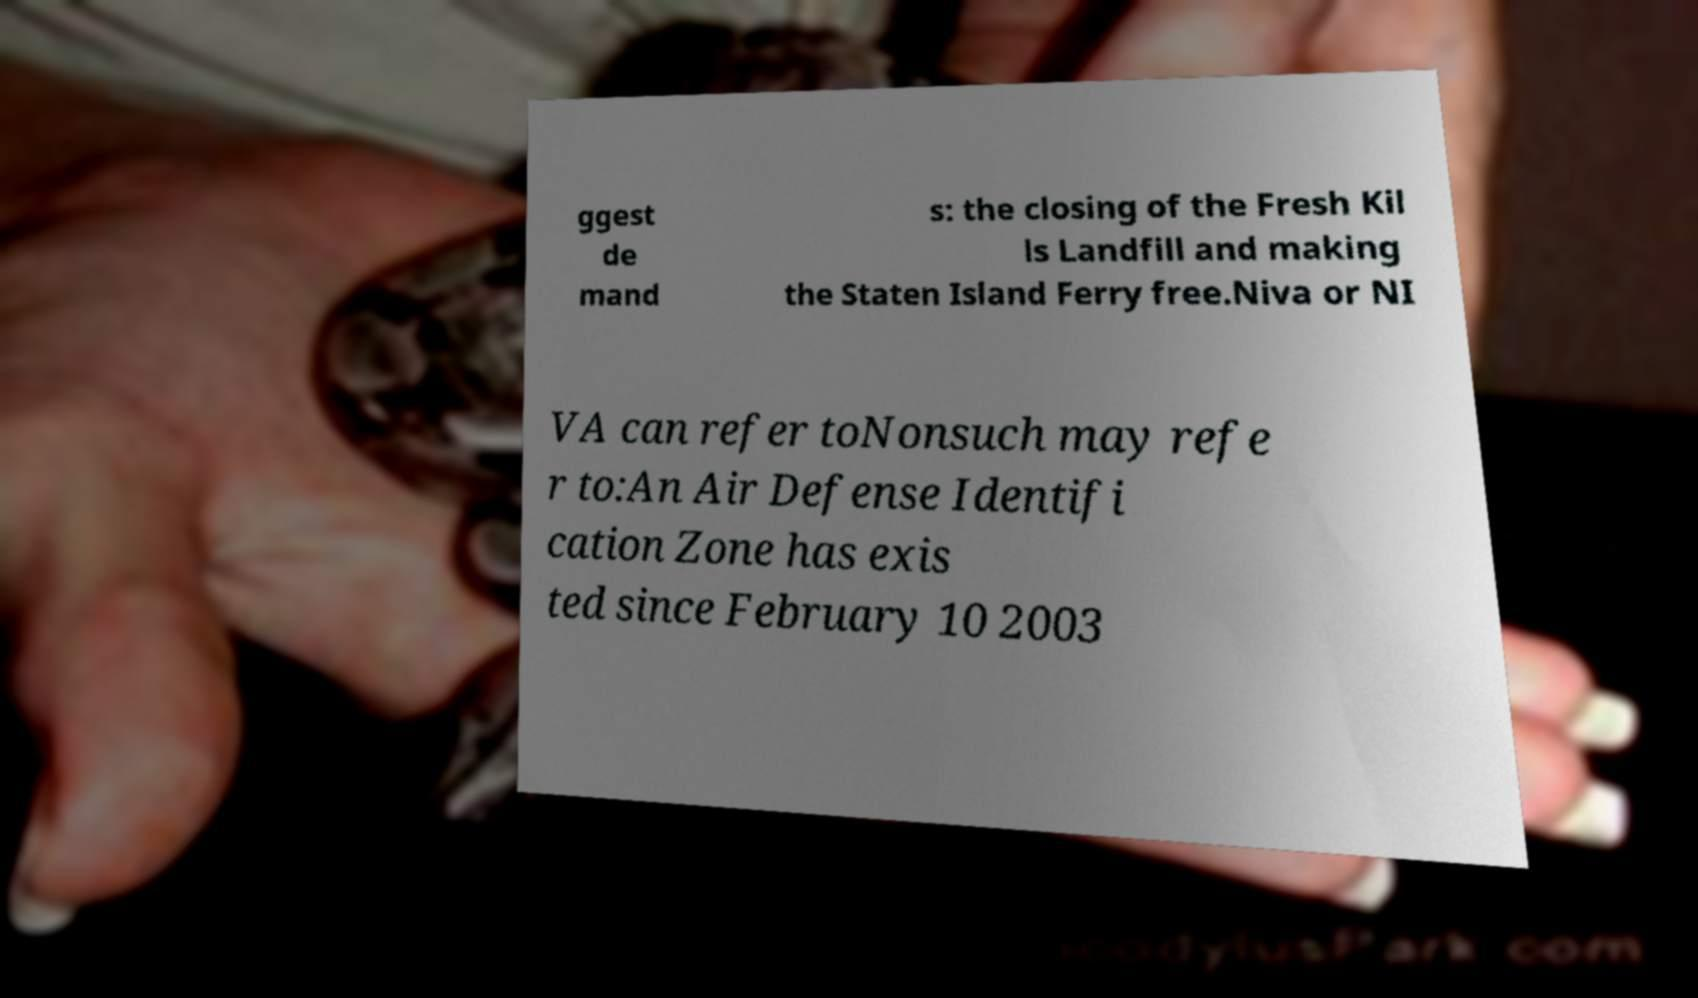I need the written content from this picture converted into text. Can you do that? ggest de mand s: the closing of the Fresh Kil ls Landfill and making the Staten Island Ferry free.Niva or NI VA can refer toNonsuch may refe r to:An Air Defense Identifi cation Zone has exis ted since February 10 2003 